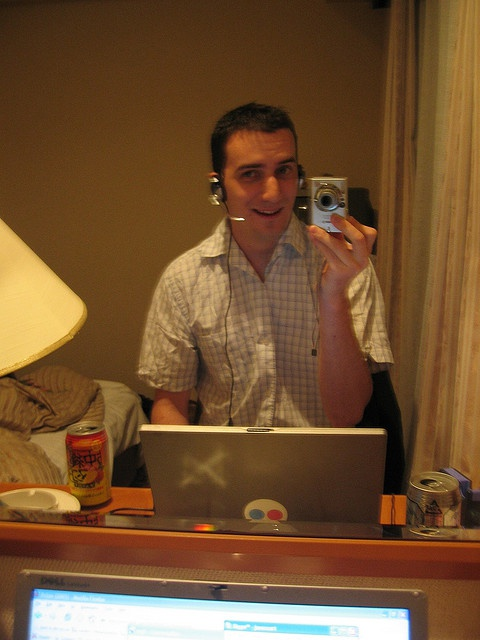Describe the objects in this image and their specific colors. I can see people in black, maroon, gray, and brown tones, laptop in black, maroon, and khaki tones, bed in black, olive, and maroon tones, and bowl in black, tan, olive, and maroon tones in this image. 